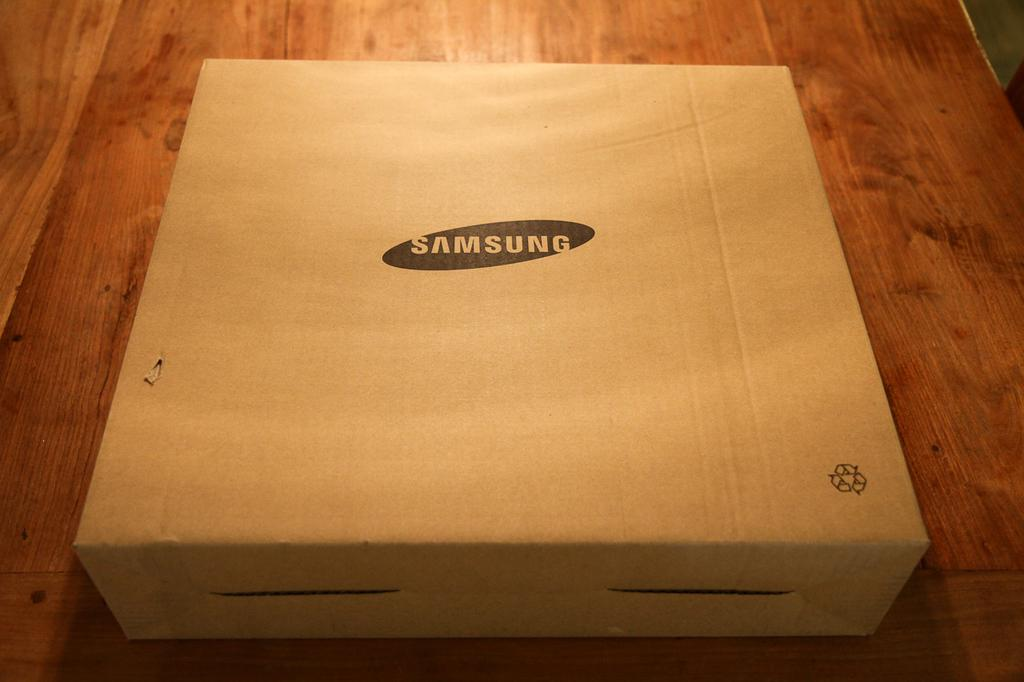<image>
Present a compact description of the photo's key features. a cardboard box that says 'samsung' in a black oval 